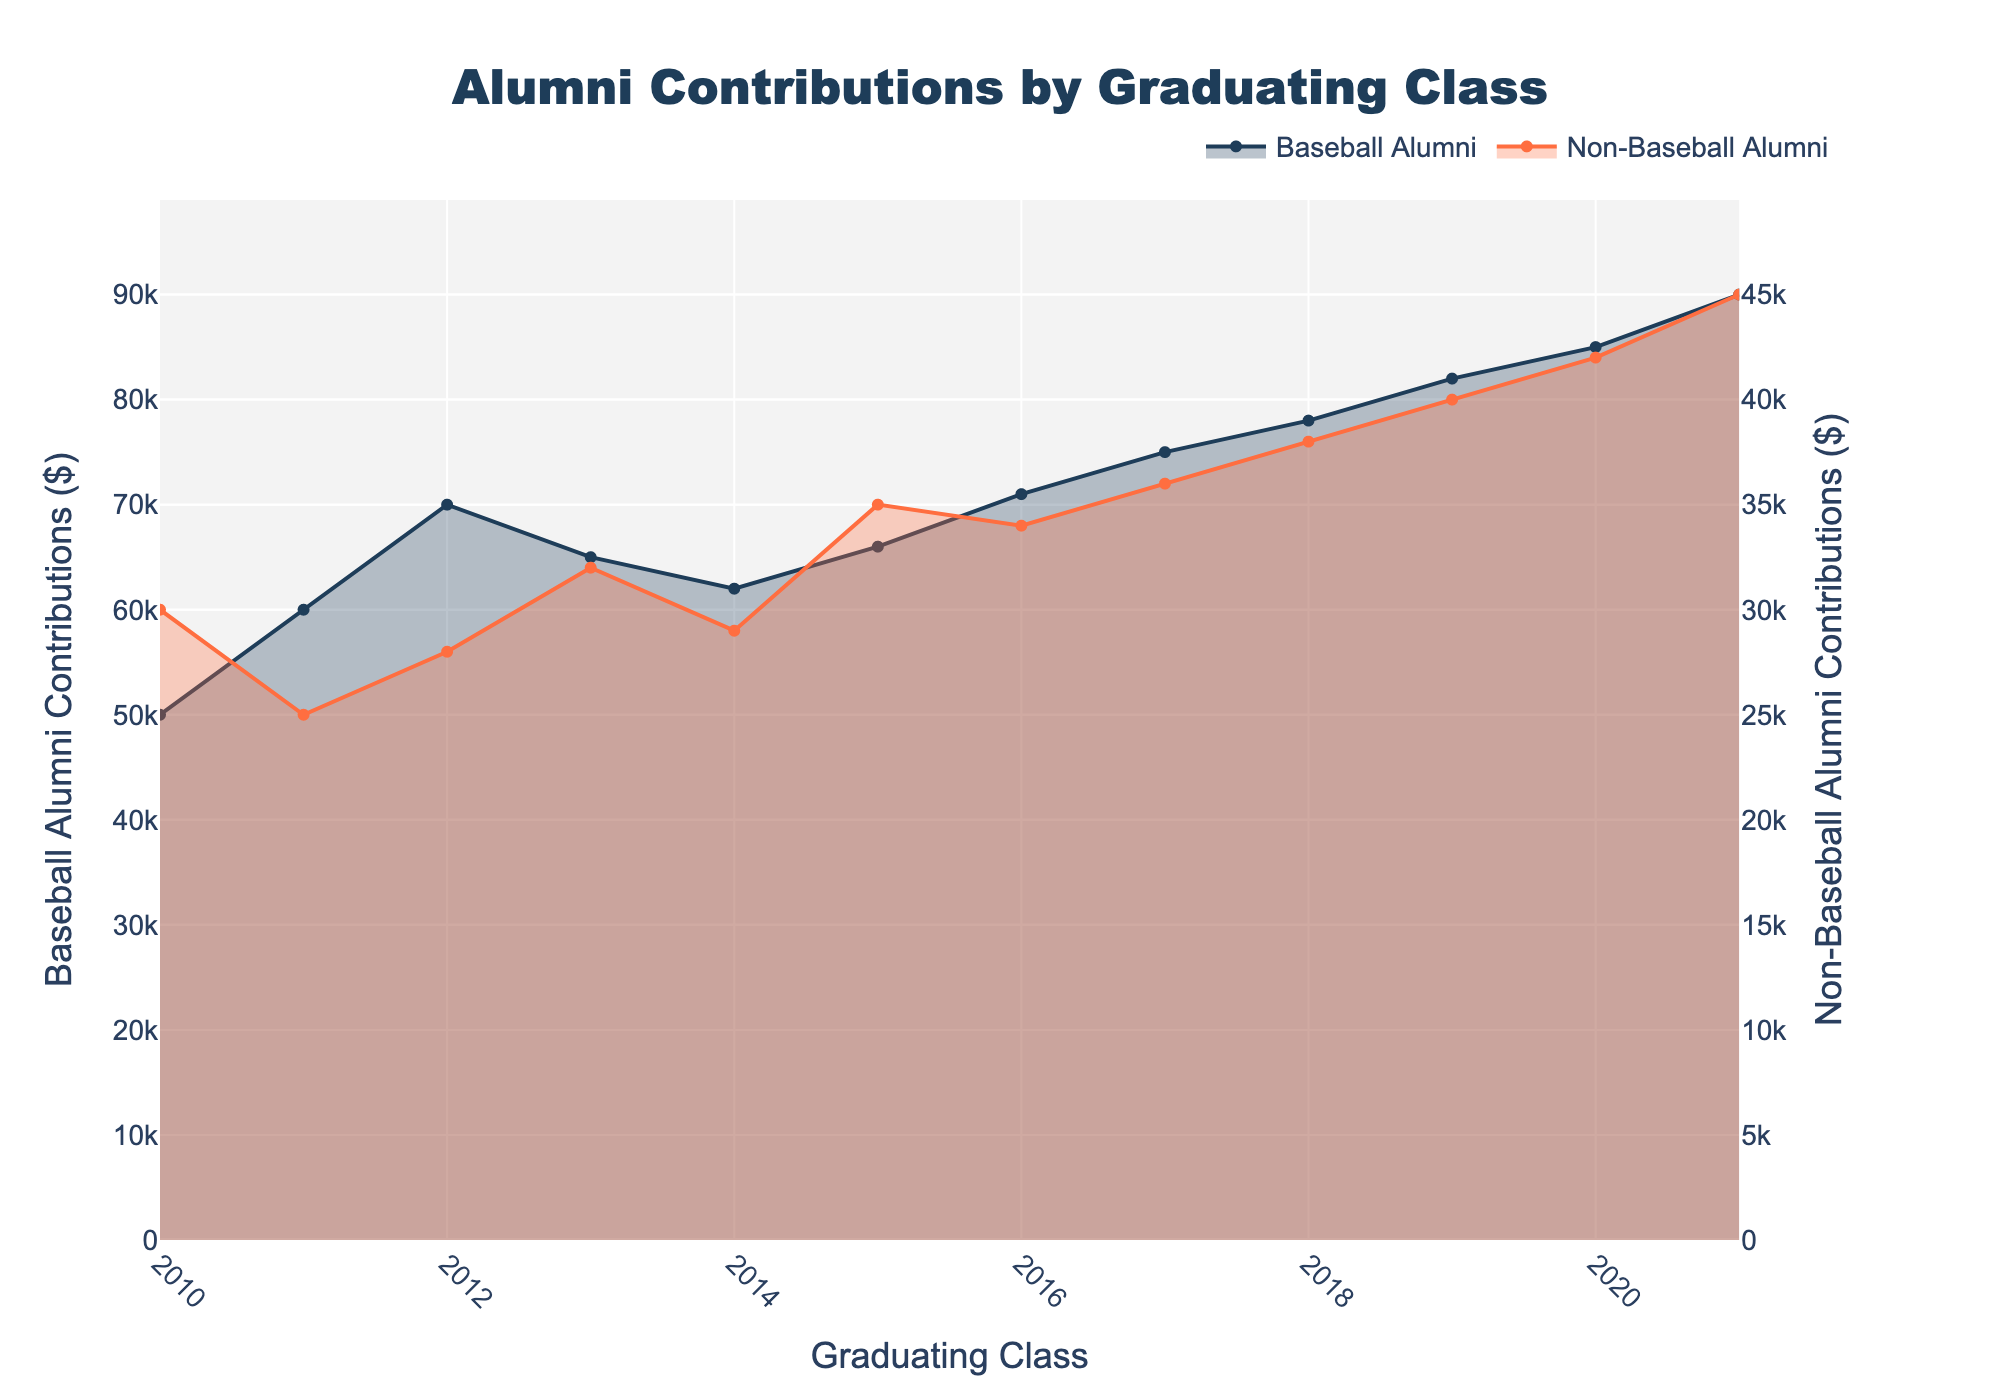what is the title of the figure? The title of the figure is usually displayed at the top of the plot. In this case, the title is specified in the code as "Alumni Contributions by Graduating Class".
Answer: Alumni Contributions by Graduating Class What are the years displayed on the x-axis? The x-axis in the area chart represents the graduating classes. The data provided lists the classes from 2010 to 2021.
Answer: 2010 to 2021 How does the contribution of Baseball Alumni in the class of 2016 compare with that of Non-Baseball Alumni in the same year? To compare, look at the 2016 graduating class data in the figure. The baseball alumni contributions are listed at $71,000 and non-baseball alumni contributions are $34,000.
Answer: $71,000 vs $34,000 Which graduating class has the highest contributions from non-baseball alumni? Check the highest point of the non-baseball alumni area on the chart. You will see that it occurs in the class of 2021 with $45,000.
Answer: Class of 2021 What is the overall trend in contributions from Baseball Alumni from 2010 to 2021? To determine the trend, observe the curve of the baseball alumni contributions. Contributions increase almost every year, showing an upward trend over time.
Answer: Upward trend How much more did Baseball Alumni contribute in 2021 compared to their contributions in 2010? Subtract the 2010 contributions of baseball alumni ($50,000) from the 2021 contributions ($90,000).
Answer: $40,000 By how much did Non-Baseball Alumni contributions increase from 2011 to 2020? Subtract the 2011 non-baseball alumni contributions ($25,000) from the 2020 contributions ($42,000).
Answer: $17,000 Which group shows a more consistent increase in contributions over the years: Baseball Alumni or Non-Baseball Alumni? To answer this, compare the visual consistency of the contribution trends. Baseball Alumni contributions show a more consistent increase compared to the more fluctuating trend of Non-Baseball Alumni contributions.
Answer: Baseball Alumni During which years did contributions from Baseball Alumni and Non-Baseball Alumni both increase compared to the previous year? Compare the values year-by-year for both contributing groups. Both groups' contributions increased from 2017 to 2018, 2018 to 2019, and 2019 to 2020.
Answer: 2017 to 2018, 2018 to 2019, and 2019 to 2020 